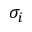<formula> <loc_0><loc_0><loc_500><loc_500>\sigma _ { i }</formula> 